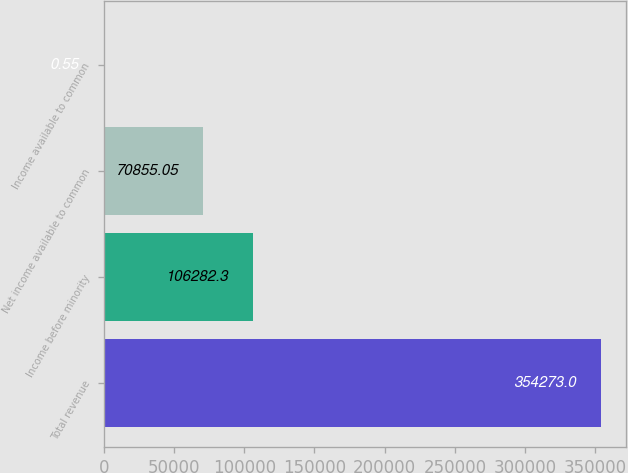Convert chart. <chart><loc_0><loc_0><loc_500><loc_500><bar_chart><fcel>Total revenue<fcel>Income before minority<fcel>Net income available to common<fcel>Income available to common<nl><fcel>354273<fcel>106282<fcel>70855.1<fcel>0.55<nl></chart> 